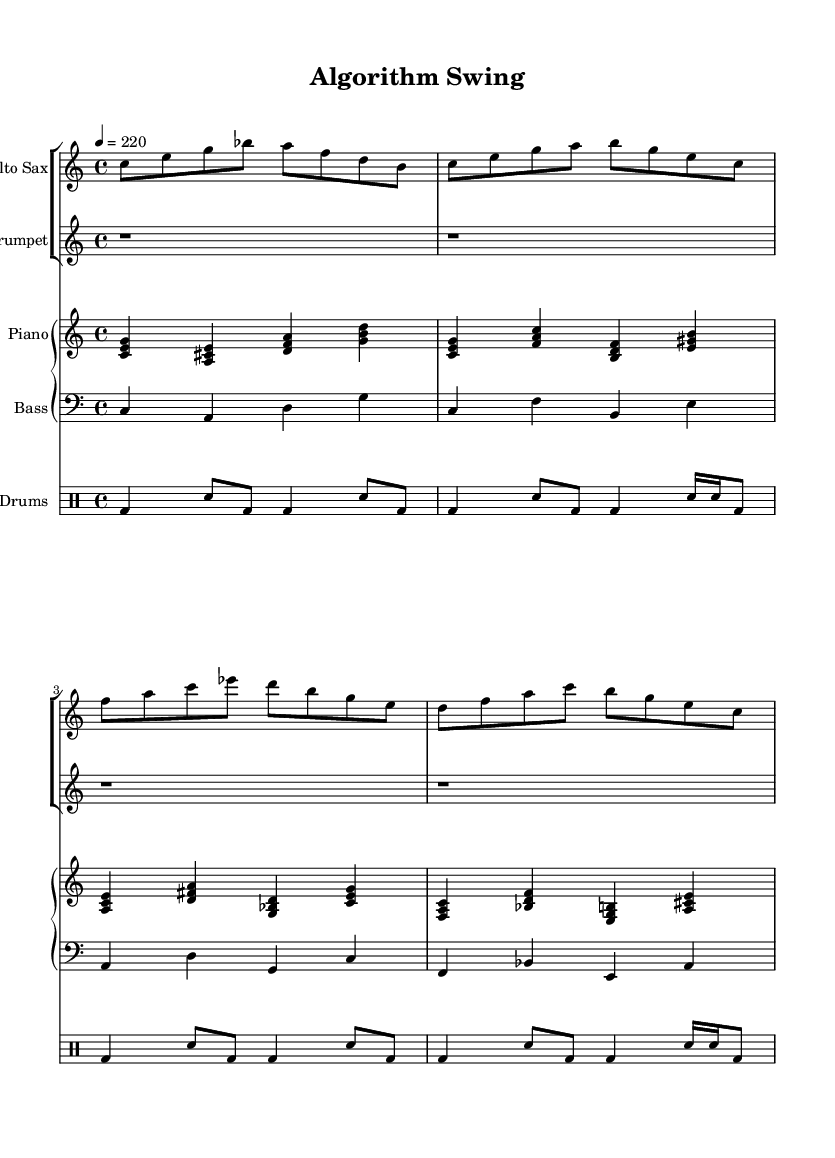What is the key signature of this music? The key signature is C major, which is noted at the beginning of the piece and has no sharps or flats indicated.
Answer: C major What is the time signature of this music? The time signature is 4/4, which is evident at the beginning of the sheet music where it is set to indicate four beats per measure.
Answer: 4/4 What is the tempo marking of this piece? The tempo marking indicates a speed of quarter note equals 220 beats per minute, which is stated at the beginning with the tempo indication.
Answer: 220 How many bars are in the alto saxophone part? The alto saxophone part contains eight bars, which can be counted by identifying the measure lines in the staff for that instrument.
Answer: 8 Which instrument has a rest in the first four measures? The trumpet part has a rest in the first four measures, as it shows only rests (noted as r1) during this time frame at the start of the piece.
Answer: Trumpet What rhythmic pattern is repeated in the drums? The drums exhibit a pattern of bass drum and snare drum that repeats consistently, specifically in the first four measures where the sequence is maintained.
Answer: Bass and snare pattern Which two instruments share the same staff for their notation? The piano and bass share the same piano staff and are indicated together, as seen in the grouping shown in the score.
Answer: Piano and Bass 